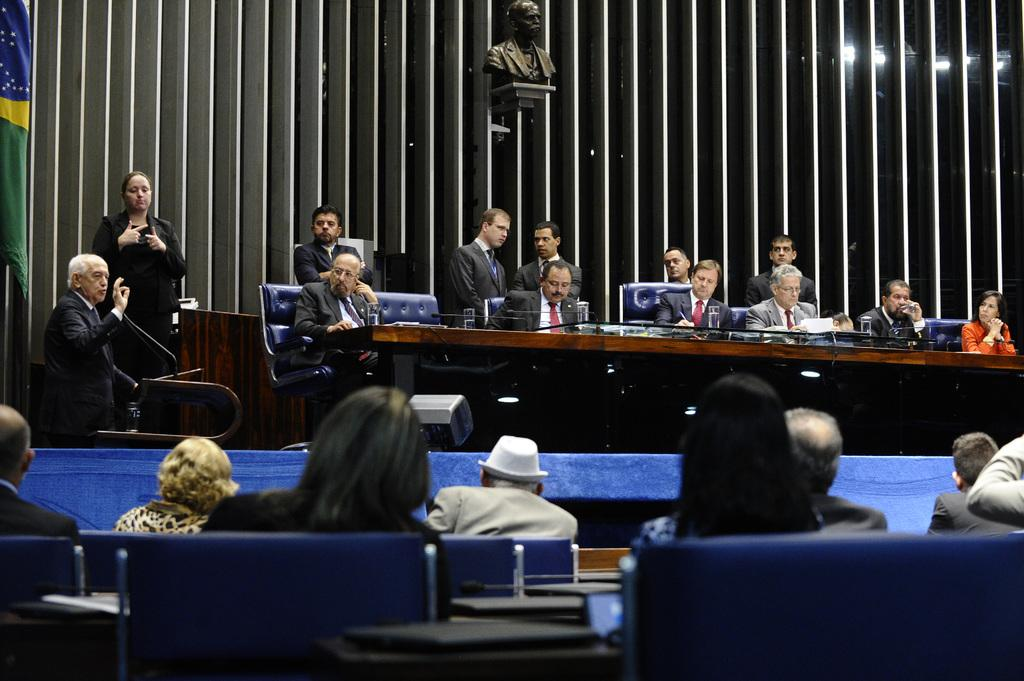What are the men in the image doing? The men in the image are standing and sitting in a meeting room. Where are the men located in relation to the table? The men are behind a table in the image. What can be seen in the middle of the room? There is a sculpture in the middle of the room. What type of bread is being served at the meeting in the image? There is no bread visible in the image, and it does not mention any food being served. 